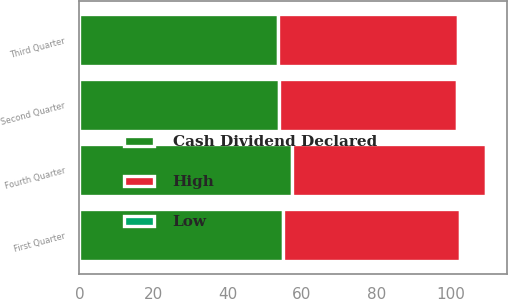Convert chart to OTSL. <chart><loc_0><loc_0><loc_500><loc_500><stacked_bar_chart><ecel><fcel>First Quarter<fcel>Second Quarter<fcel>Third Quarter<fcel>Fourth Quarter<nl><fcel>Cash Dividend Declared<fcel>54.76<fcel>53.92<fcel>53.56<fcel>57.44<nl><fcel>High<fcel>47.94<fcel>48<fcel>48.54<fcel>52.12<nl><fcel>Low<fcel>0.33<fcel>0.36<fcel>0.36<fcel>0.36<nl></chart> 